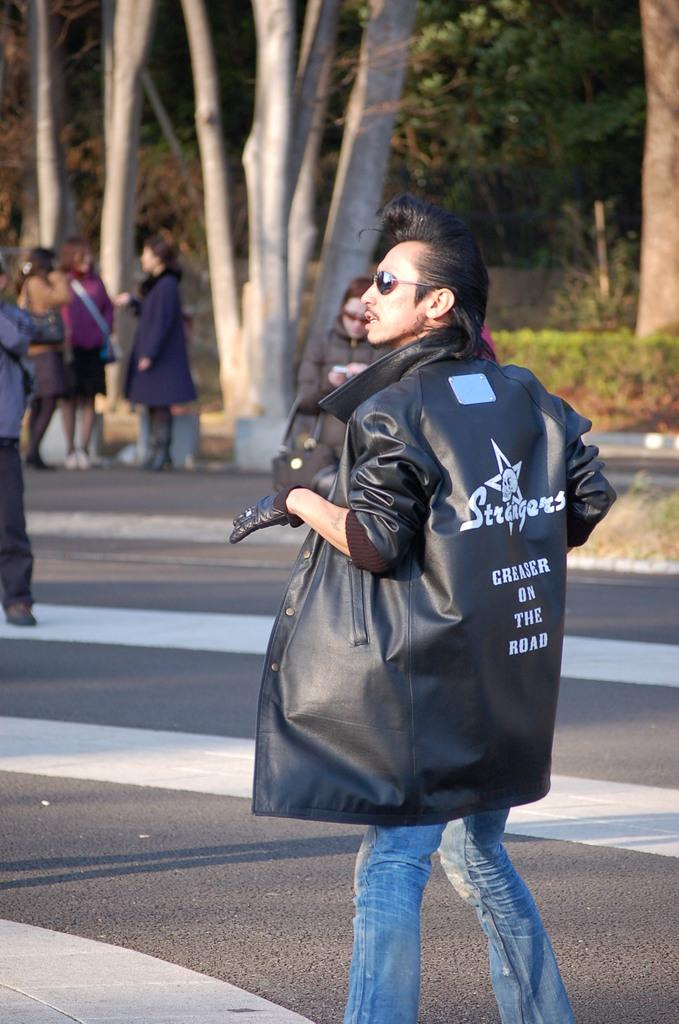What can be seen in the image? There are people standing in the image. What is visible in the background of the image? There are trees and plants in the background of the image. Where is the cave located in the image? There is no cave present in the image. What type of drink is being served in the stocking in the image? There is no stocking or drink present in the image. 